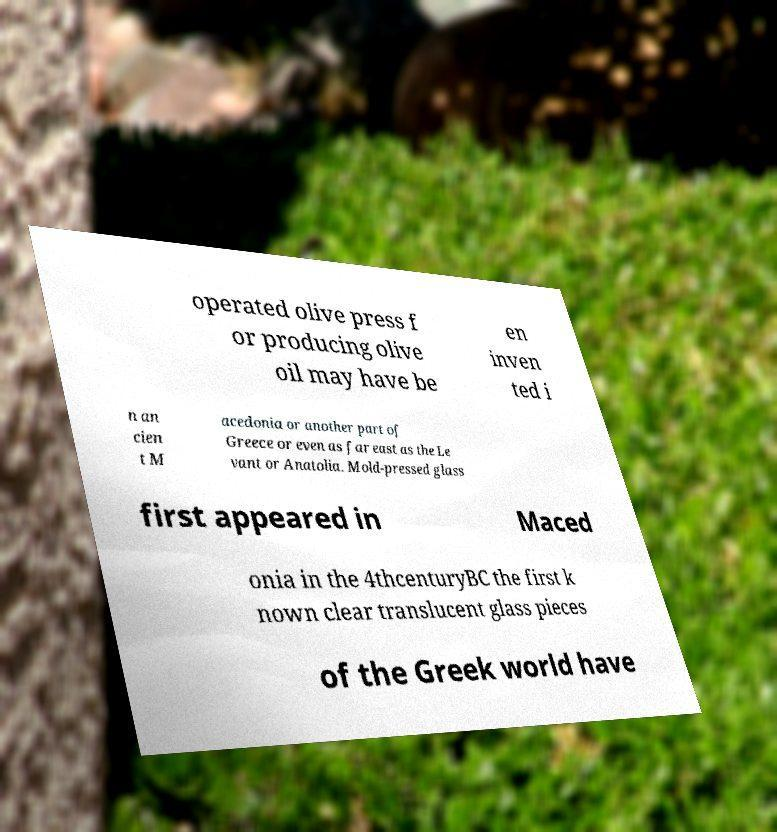Can you accurately transcribe the text from the provided image for me? operated olive press f or producing olive oil may have be en inven ted i n an cien t M acedonia or another part of Greece or even as far east as the Le vant or Anatolia. Mold-pressed glass first appeared in Maced onia in the 4thcenturyBC the first k nown clear translucent glass pieces of the Greek world have 